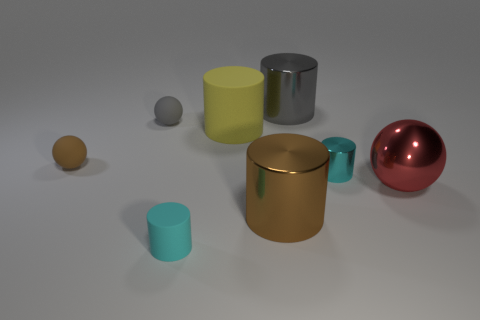Subtract all gray balls. How many balls are left? 2 Add 1 gray spheres. How many objects exist? 9 Subtract all cylinders. How many objects are left? 3 Subtract all brown cylinders. How many cylinders are left? 4 Subtract 1 spheres. How many spheres are left? 2 Subtract all blue spheres. Subtract all green cylinders. How many spheres are left? 3 Subtract all yellow cylinders. How many green balls are left? 0 Subtract all big yellow blocks. Subtract all cylinders. How many objects are left? 3 Add 3 small brown things. How many small brown things are left? 4 Add 4 large brown shiny balls. How many large brown shiny balls exist? 4 